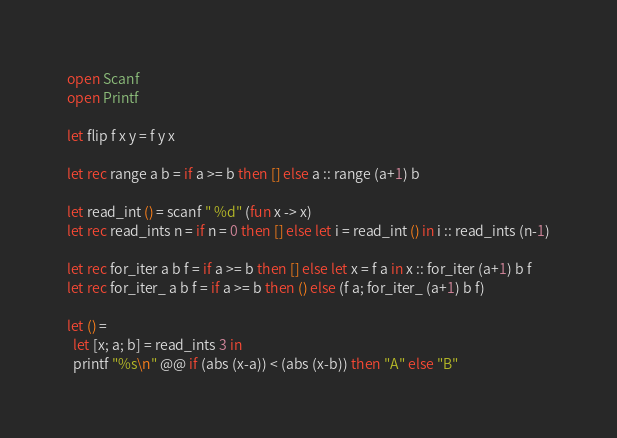Convert code to text. <code><loc_0><loc_0><loc_500><loc_500><_OCaml_>
open Scanf
open Printf

let flip f x y = f y x

let rec range a b = if a >= b then [] else a :: range (a+1) b

let read_int () = scanf " %d" (fun x -> x)
let rec read_ints n = if n = 0 then [] else let i = read_int () in i :: read_ints (n-1)

let rec for_iter a b f = if a >= b then [] else let x = f a in x :: for_iter (a+1) b f
let rec for_iter_ a b f = if a >= b then () else (f a; for_iter_ (a+1) b f)

let () =
  let [x; a; b] = read_ints 3 in
  printf "%s\n" @@ if (abs (x-a)) < (abs (x-b)) then "A" else "B"
</code> 